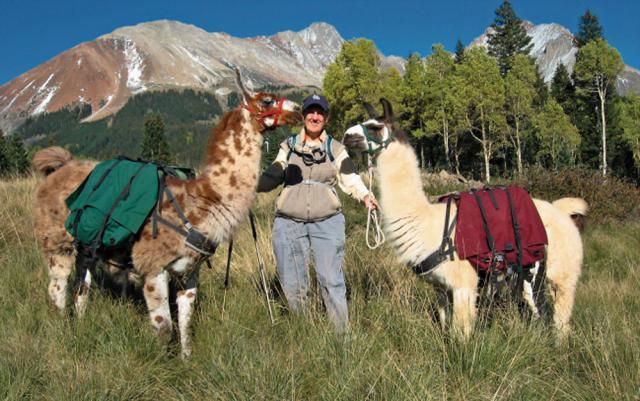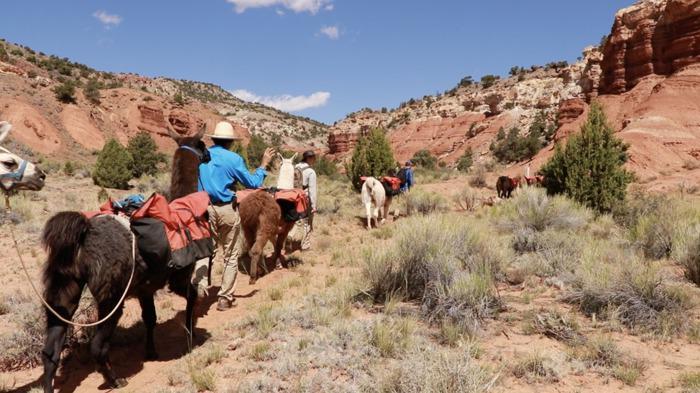The first image is the image on the left, the second image is the image on the right. Analyze the images presented: Is the assertion "The right image includes a person leading a llama toward the camera, and the left image includes multiple llamas wearing packs." valid? Answer yes or no. No. The first image is the image on the left, the second image is the image on the right. Given the left and right images, does the statement "Some llamas are facing the other way." hold true? Answer yes or no. Yes. 